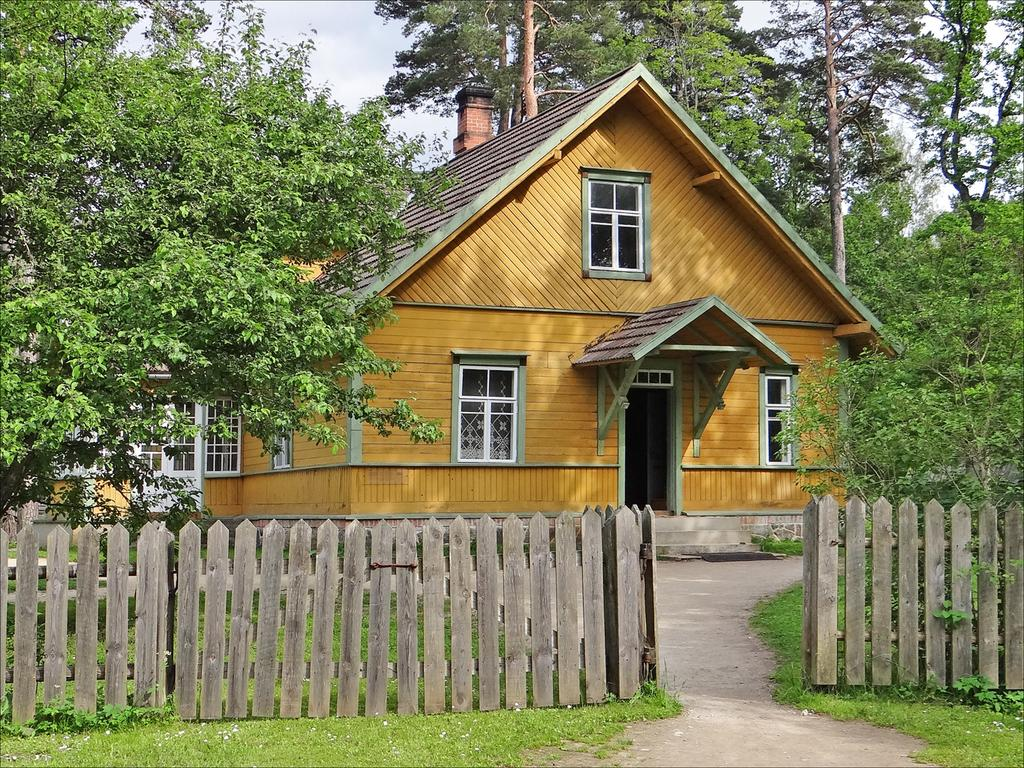What type of structure is present in the image? There is a house in the image. What is located near the house? There is a wooden fence in the image. What type of vegetation can be seen in the image? There is green grass and green trees in the image. What is visible at the top of the image? The sky is visible at the top of the image. Can you see a deer eating an orange next to the sister in the image? There is no deer, orange, or sister present in the image. 